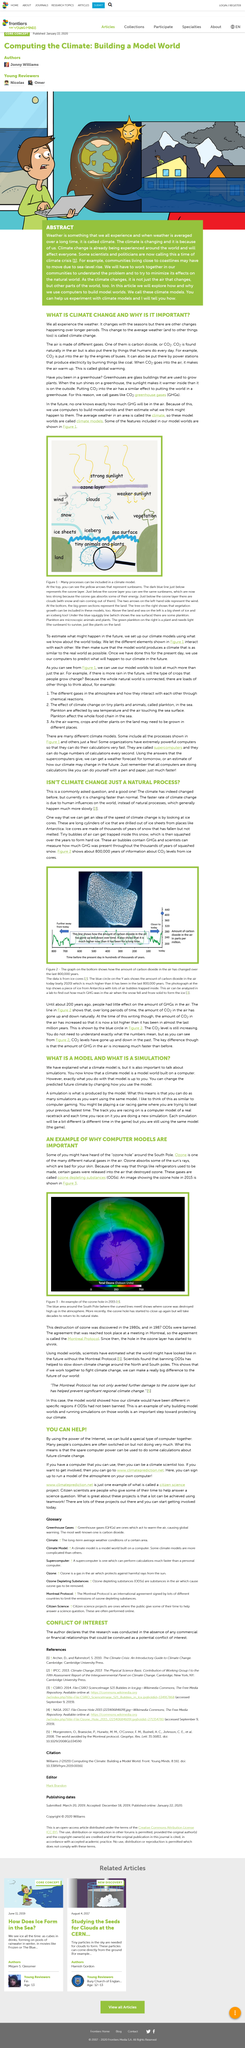Indicate a few pertinent items in this graphic. In 2015, the image was taken. The speed of climate change can be determined by analyzing ice cores, providing insight into the rate at which the Earth's climate is changing. Climate change is the change in the average weather patterns, which can result in variations in temperature, precipitation, and wind patterns, leading to adverse effects on the environment and human societies. The ozone layer was discovered in 1980. Greenhouse gases, such as carbon dioxide, are commonly referred to as gases that have a similar name. 